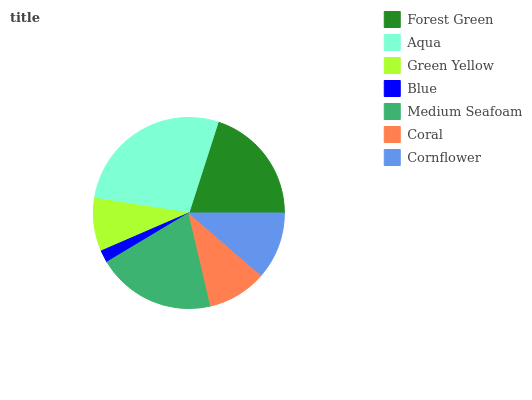Is Blue the minimum?
Answer yes or no. Yes. Is Aqua the maximum?
Answer yes or no. Yes. Is Green Yellow the minimum?
Answer yes or no. No. Is Green Yellow the maximum?
Answer yes or no. No. Is Aqua greater than Green Yellow?
Answer yes or no. Yes. Is Green Yellow less than Aqua?
Answer yes or no. Yes. Is Green Yellow greater than Aqua?
Answer yes or no. No. Is Aqua less than Green Yellow?
Answer yes or no. No. Is Cornflower the high median?
Answer yes or no. Yes. Is Cornflower the low median?
Answer yes or no. Yes. Is Blue the high median?
Answer yes or no. No. Is Green Yellow the low median?
Answer yes or no. No. 